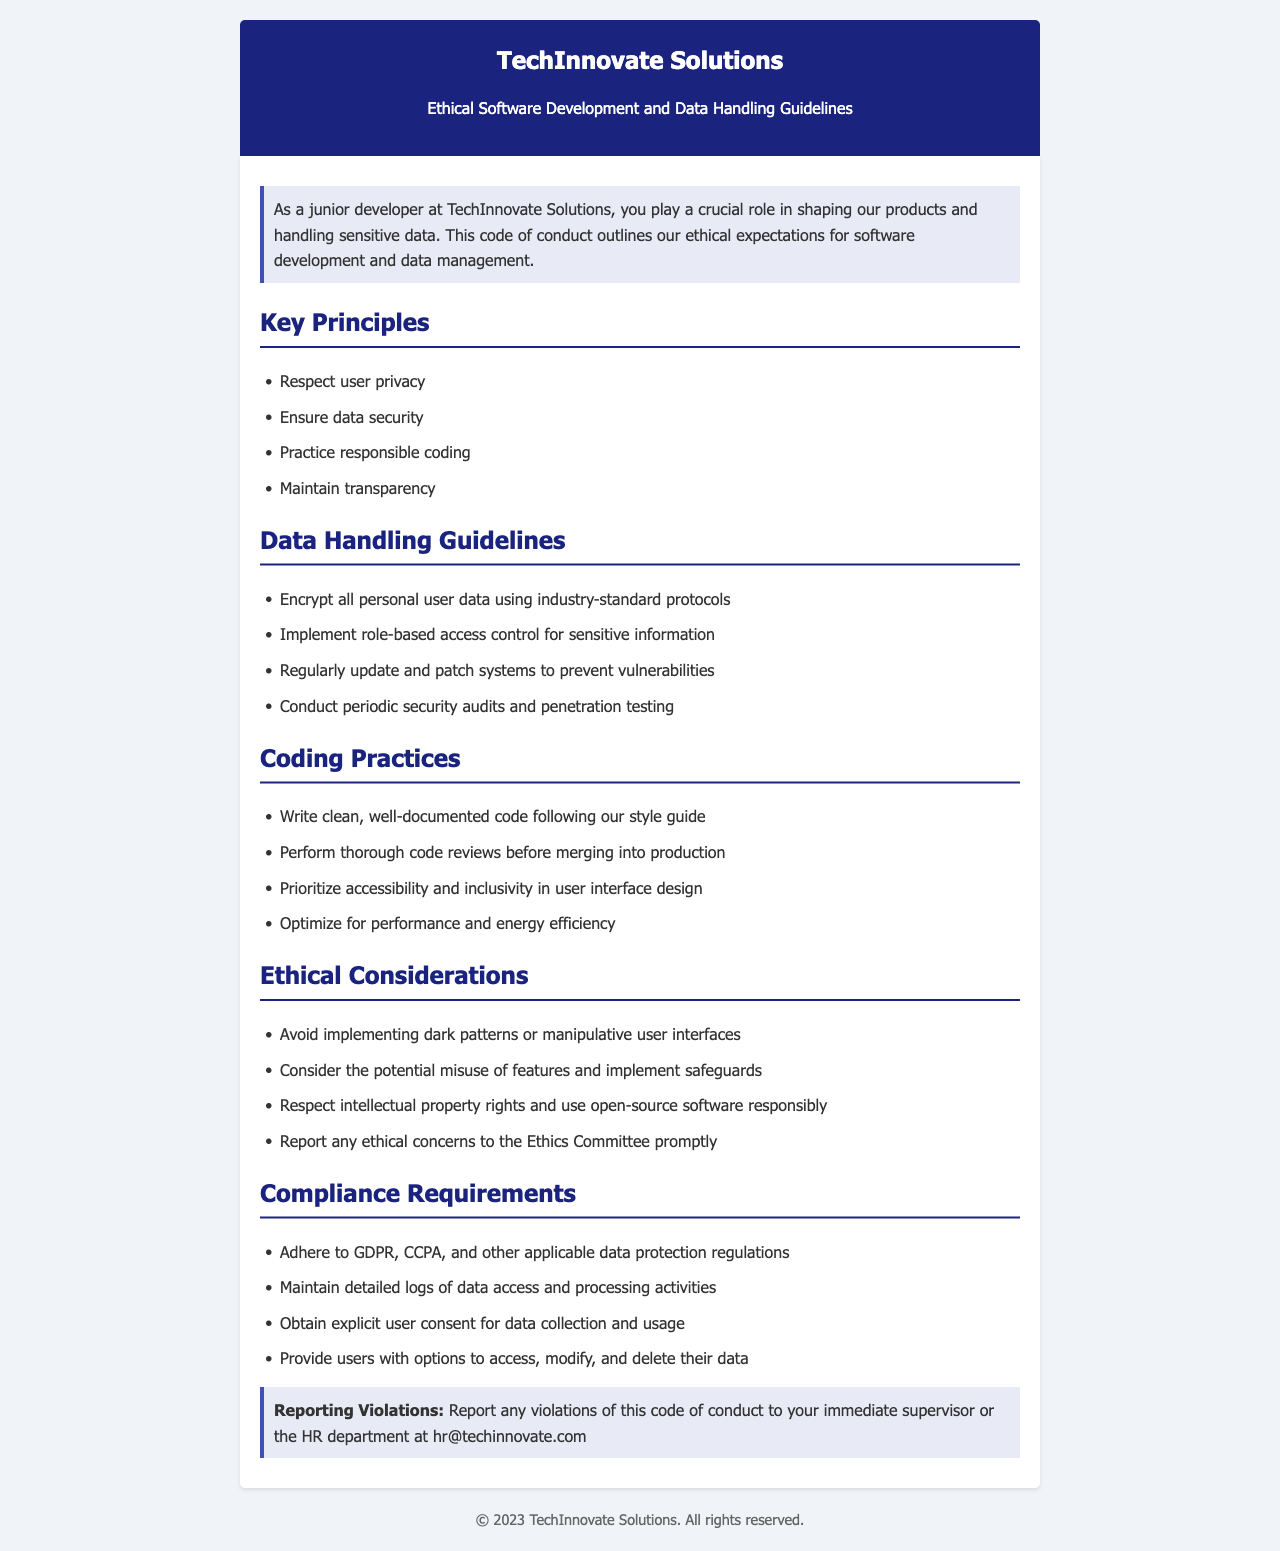What is the title of the document? The title of the document is specified in the header section, which indicates the purpose of the content.
Answer: Ethical Software Development and Data Handling Guidelines How many key principles are outlined in the document? The document includes a list of key principles pertaining to ethical behavior, which can be counted from the relevant section.
Answer: Four What guideline is given for encrypting user data? The document specifies that all personal user data must be encrypted following certain protocols, indicating the necessity of security.
Answer: Encrypt all personal user data using industry-standard protocols What practice is recommended before merging code into production? The document presents a coding practice that prioritizes code quality, which involves a specific type of review before code integration.
Answer: Perform thorough code reviews Which ethical consideration avoids manipulative user interfaces? The document highlights the importance of ethical design choices, emphasizing the need to avoid certain practices that may harm users.
Answer: Avoid implementing dark patterns or manipulative user interfaces What does GDPR stand for as mentioned in the compliance requirements? The document refers to regulatory requirements that are designed to protect user information.
Answer: General Data Protection Regulation Who should violations of the code be reported to? The document identifies the appropriate channels for reporting ethical concerns related to the code of conduct.
Answer: Immediate supervisor or the HR department What is the company's official email for reporting violations? The document provides specific contact information for reporting ethical issues, highlighting the importance of communication within the organization.
Answer: hr@techinnovate.com 